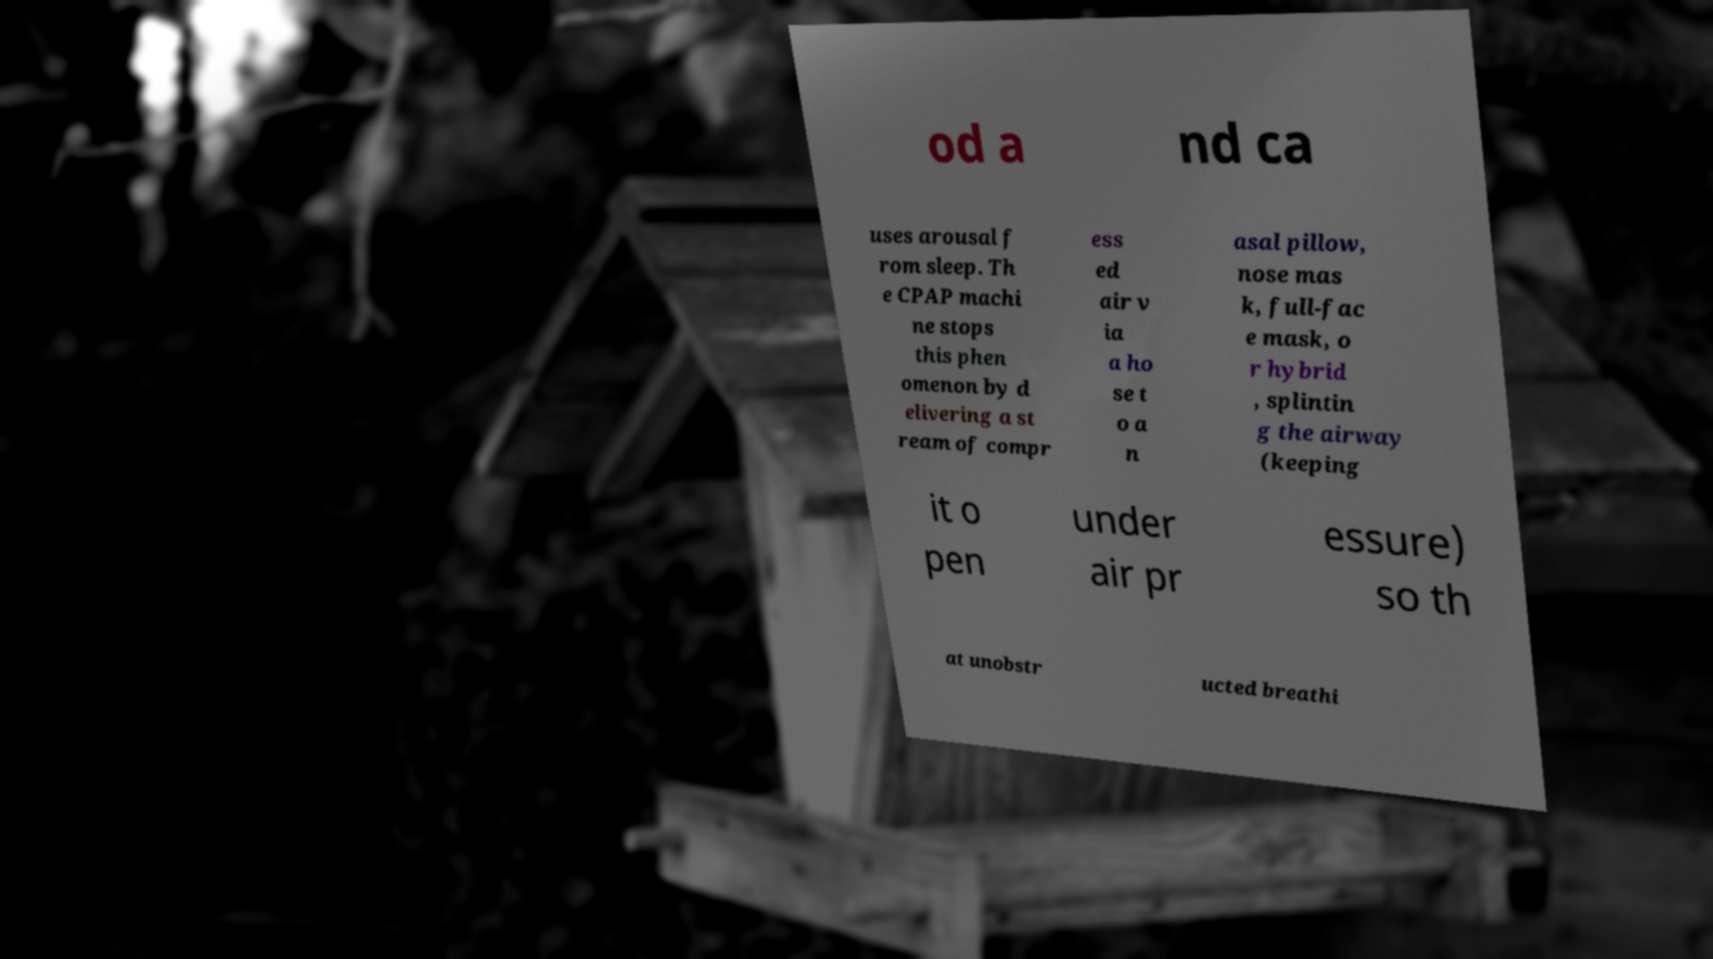I need the written content from this picture converted into text. Can you do that? od a nd ca uses arousal f rom sleep. Th e CPAP machi ne stops this phen omenon by d elivering a st ream of compr ess ed air v ia a ho se t o a n asal pillow, nose mas k, full-fac e mask, o r hybrid , splintin g the airway (keeping it o pen under air pr essure) so th at unobstr ucted breathi 